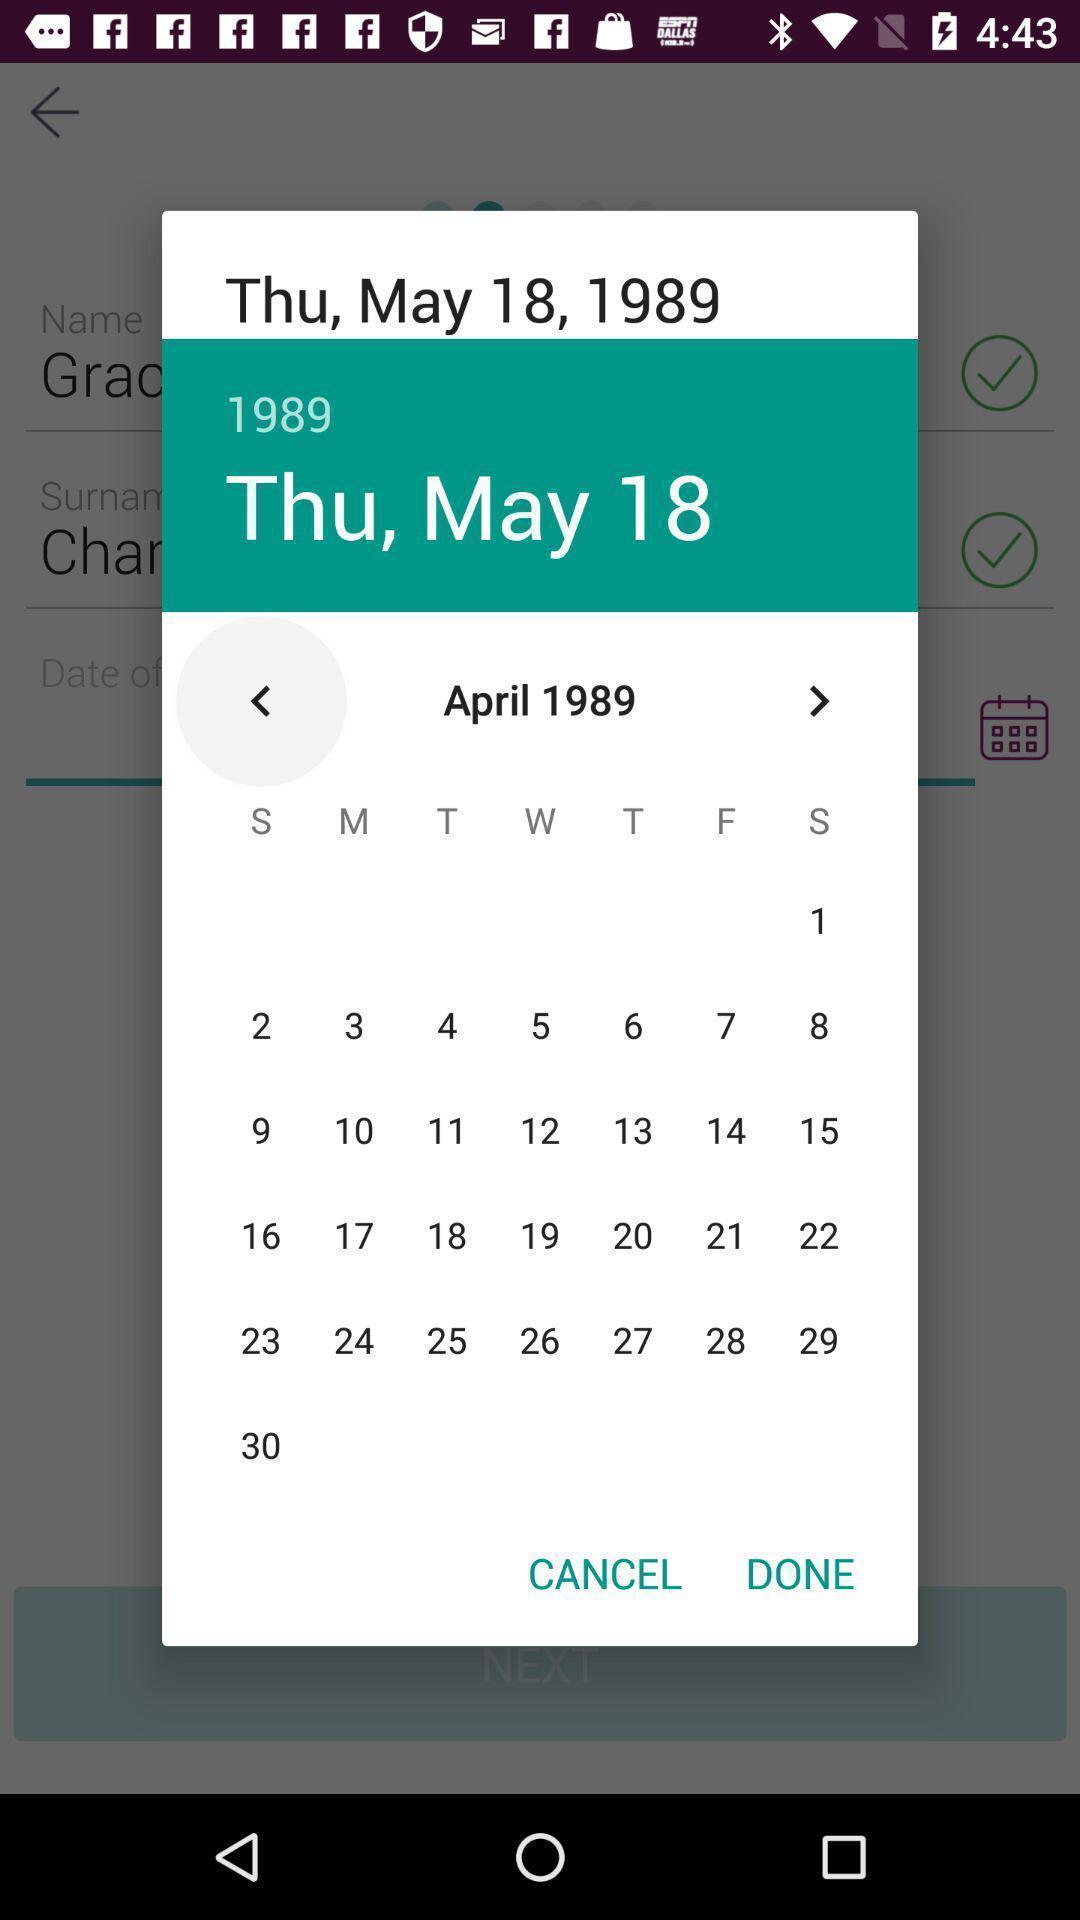Give me a summary of this screen capture. Pop up window of calendar. 